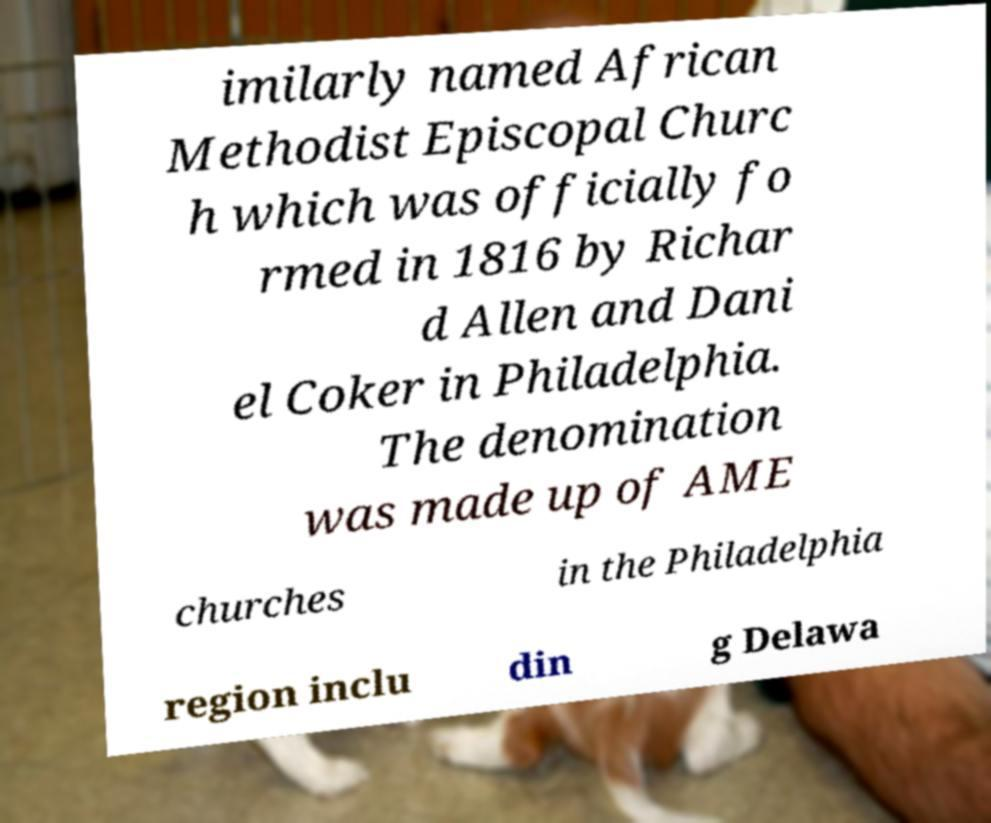Could you assist in decoding the text presented in this image and type it out clearly? imilarly named African Methodist Episcopal Churc h which was officially fo rmed in 1816 by Richar d Allen and Dani el Coker in Philadelphia. The denomination was made up of AME churches in the Philadelphia region inclu din g Delawa 